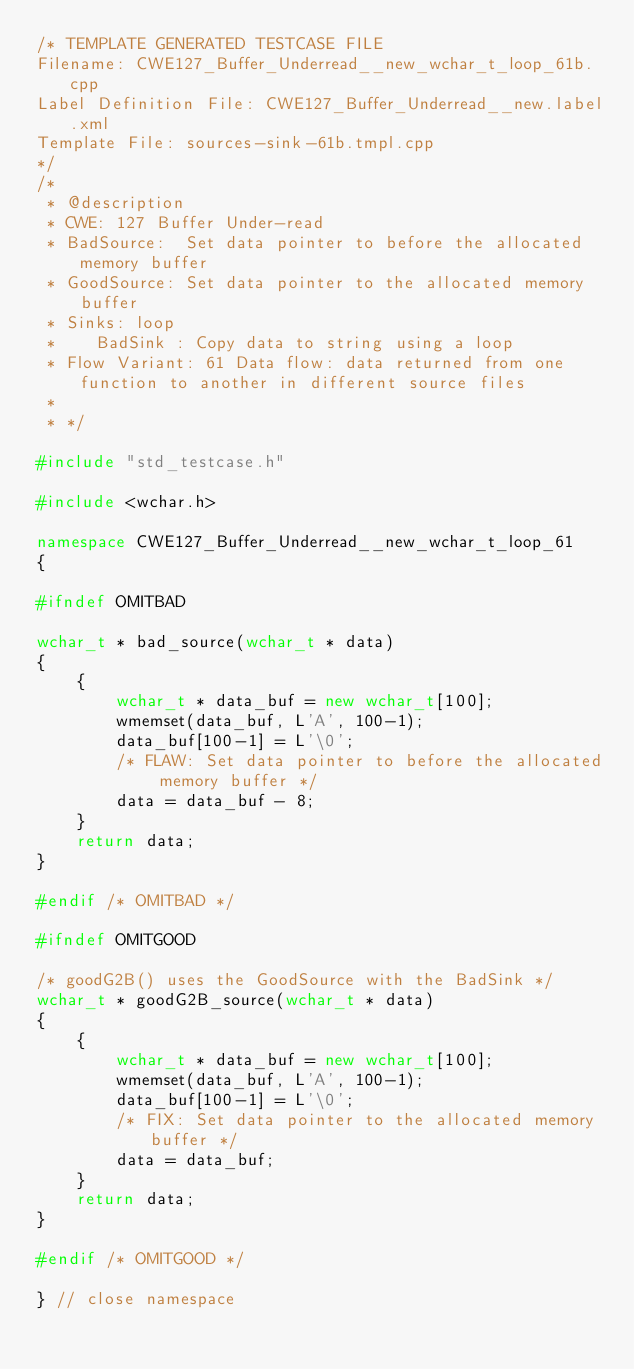Convert code to text. <code><loc_0><loc_0><loc_500><loc_500><_C++_>/* TEMPLATE GENERATED TESTCASE FILE
Filename: CWE127_Buffer_Underread__new_wchar_t_loop_61b.cpp
Label Definition File: CWE127_Buffer_Underread__new.label.xml
Template File: sources-sink-61b.tmpl.cpp
*/
/*
 * @description
 * CWE: 127 Buffer Under-read
 * BadSource:  Set data pointer to before the allocated memory buffer
 * GoodSource: Set data pointer to the allocated memory buffer
 * Sinks: loop
 *    BadSink : Copy data to string using a loop
 * Flow Variant: 61 Data flow: data returned from one function to another in different source files
 *
 * */

#include "std_testcase.h"

#include <wchar.h>

namespace CWE127_Buffer_Underread__new_wchar_t_loop_61
{

#ifndef OMITBAD

wchar_t * bad_source(wchar_t * data)
{
    {
        wchar_t * data_buf = new wchar_t[100];
        wmemset(data_buf, L'A', 100-1);
        data_buf[100-1] = L'\0';
        /* FLAW: Set data pointer to before the allocated memory buffer */
        data = data_buf - 8;
    }
    return data;
}

#endif /* OMITBAD */

#ifndef OMITGOOD

/* goodG2B() uses the GoodSource with the BadSink */
wchar_t * goodG2B_source(wchar_t * data)
{
    {
        wchar_t * data_buf = new wchar_t[100];
        wmemset(data_buf, L'A', 100-1);
        data_buf[100-1] = L'\0';
        /* FIX: Set data pointer to the allocated memory buffer */
        data = data_buf;
    }
    return data;
}

#endif /* OMITGOOD */

} // close namespace
</code> 